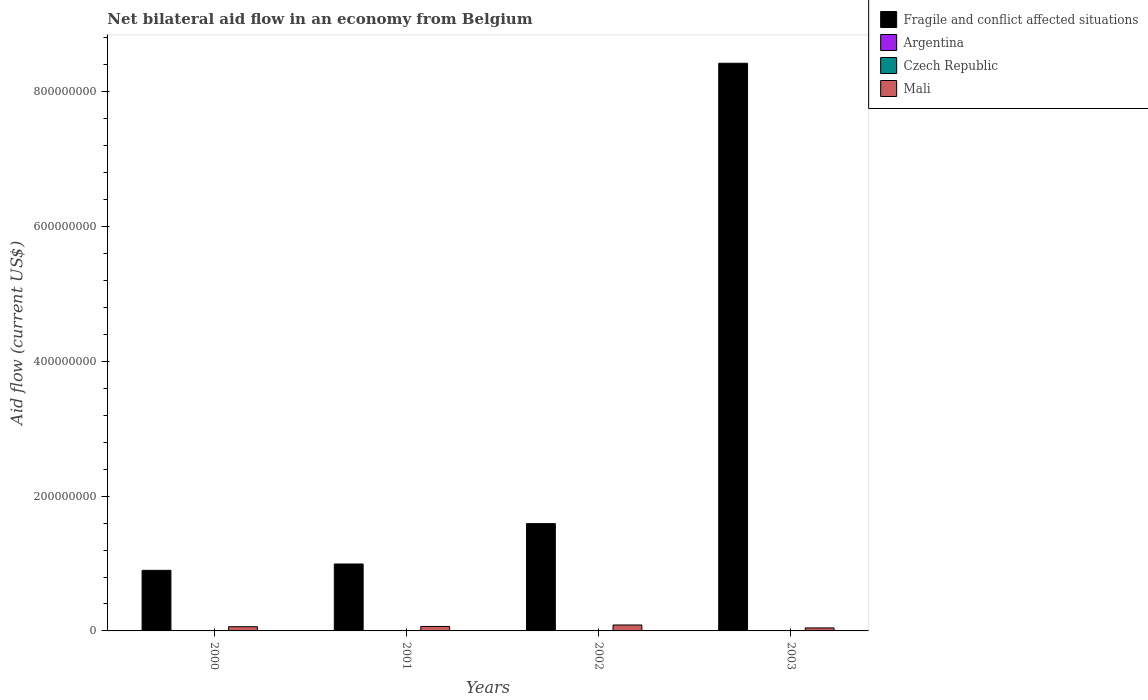How many different coloured bars are there?
Provide a short and direct response. 4. How many groups of bars are there?
Your answer should be very brief. 4. Are the number of bars on each tick of the X-axis equal?
Your answer should be very brief. Yes. What is the label of the 2nd group of bars from the left?
Give a very brief answer. 2001. Across all years, what is the maximum net bilateral aid flow in Mali?
Make the answer very short. 8.81e+06. Across all years, what is the minimum net bilateral aid flow in Fragile and conflict affected situations?
Your answer should be compact. 8.99e+07. In which year was the net bilateral aid flow in Mali maximum?
Offer a very short reply. 2002. What is the total net bilateral aid flow in Fragile and conflict affected situations in the graph?
Offer a terse response. 1.19e+09. What is the difference between the net bilateral aid flow in Mali in 2000 and that in 2001?
Keep it short and to the point. -3.70e+05. What is the difference between the net bilateral aid flow in Czech Republic in 2003 and the net bilateral aid flow in Mali in 2002?
Provide a short and direct response. -8.23e+06. What is the average net bilateral aid flow in Argentina per year?
Ensure brevity in your answer.  4.32e+05. In the year 2001, what is the difference between the net bilateral aid flow in Argentina and net bilateral aid flow in Mali?
Give a very brief answer. -6.14e+06. What is the ratio of the net bilateral aid flow in Mali in 2000 to that in 2001?
Ensure brevity in your answer.  0.94. What is the difference between the highest and the lowest net bilateral aid flow in Argentina?
Your answer should be very brief. 2.20e+05. Is it the case that in every year, the sum of the net bilateral aid flow in Argentina and net bilateral aid flow in Czech Republic is greater than the sum of net bilateral aid flow in Fragile and conflict affected situations and net bilateral aid flow in Mali?
Provide a short and direct response. No. What does the 4th bar from the right in 2001 represents?
Your answer should be very brief. Fragile and conflict affected situations. Is it the case that in every year, the sum of the net bilateral aid flow in Mali and net bilateral aid flow in Czech Republic is greater than the net bilateral aid flow in Fragile and conflict affected situations?
Provide a short and direct response. No. What is the difference between two consecutive major ticks on the Y-axis?
Give a very brief answer. 2.00e+08. Does the graph contain grids?
Provide a succinct answer. No. How are the legend labels stacked?
Ensure brevity in your answer.  Vertical. What is the title of the graph?
Offer a terse response. Net bilateral aid flow in an economy from Belgium. What is the label or title of the Y-axis?
Offer a very short reply. Aid flow (current US$). What is the Aid flow (current US$) in Fragile and conflict affected situations in 2000?
Give a very brief answer. 8.99e+07. What is the Aid flow (current US$) in Argentina in 2000?
Provide a short and direct response. 5.40e+05. What is the Aid flow (current US$) of Mali in 2000?
Offer a terse response. 6.25e+06. What is the Aid flow (current US$) of Fragile and conflict affected situations in 2001?
Give a very brief answer. 9.93e+07. What is the Aid flow (current US$) in Czech Republic in 2001?
Your answer should be very brief. 3.60e+05. What is the Aid flow (current US$) in Mali in 2001?
Make the answer very short. 6.62e+06. What is the Aid flow (current US$) in Fragile and conflict affected situations in 2002?
Ensure brevity in your answer.  1.59e+08. What is the Aid flow (current US$) of Argentina in 2002?
Offer a very short reply. 3.20e+05. What is the Aid flow (current US$) in Czech Republic in 2002?
Offer a terse response. 3.80e+05. What is the Aid flow (current US$) in Mali in 2002?
Offer a very short reply. 8.81e+06. What is the Aid flow (current US$) of Fragile and conflict affected situations in 2003?
Your answer should be compact. 8.42e+08. What is the Aid flow (current US$) of Argentina in 2003?
Make the answer very short. 3.90e+05. What is the Aid flow (current US$) of Czech Republic in 2003?
Your response must be concise. 5.80e+05. What is the Aid flow (current US$) in Mali in 2003?
Ensure brevity in your answer.  4.46e+06. Across all years, what is the maximum Aid flow (current US$) in Fragile and conflict affected situations?
Offer a very short reply. 8.42e+08. Across all years, what is the maximum Aid flow (current US$) in Argentina?
Ensure brevity in your answer.  5.40e+05. Across all years, what is the maximum Aid flow (current US$) in Czech Republic?
Keep it short and to the point. 5.80e+05. Across all years, what is the maximum Aid flow (current US$) in Mali?
Your answer should be very brief. 8.81e+06. Across all years, what is the minimum Aid flow (current US$) of Fragile and conflict affected situations?
Provide a short and direct response. 8.99e+07. Across all years, what is the minimum Aid flow (current US$) in Mali?
Give a very brief answer. 4.46e+06. What is the total Aid flow (current US$) in Fragile and conflict affected situations in the graph?
Provide a succinct answer. 1.19e+09. What is the total Aid flow (current US$) in Argentina in the graph?
Your answer should be very brief. 1.73e+06. What is the total Aid flow (current US$) in Czech Republic in the graph?
Keep it short and to the point. 1.70e+06. What is the total Aid flow (current US$) in Mali in the graph?
Make the answer very short. 2.61e+07. What is the difference between the Aid flow (current US$) of Fragile and conflict affected situations in 2000 and that in 2001?
Give a very brief answer. -9.43e+06. What is the difference between the Aid flow (current US$) of Mali in 2000 and that in 2001?
Ensure brevity in your answer.  -3.70e+05. What is the difference between the Aid flow (current US$) of Fragile and conflict affected situations in 2000 and that in 2002?
Make the answer very short. -6.93e+07. What is the difference between the Aid flow (current US$) of Mali in 2000 and that in 2002?
Your answer should be very brief. -2.56e+06. What is the difference between the Aid flow (current US$) of Fragile and conflict affected situations in 2000 and that in 2003?
Provide a short and direct response. -7.53e+08. What is the difference between the Aid flow (current US$) of Czech Republic in 2000 and that in 2003?
Make the answer very short. -2.00e+05. What is the difference between the Aid flow (current US$) in Mali in 2000 and that in 2003?
Provide a succinct answer. 1.79e+06. What is the difference between the Aid flow (current US$) of Fragile and conflict affected situations in 2001 and that in 2002?
Your response must be concise. -5.99e+07. What is the difference between the Aid flow (current US$) in Argentina in 2001 and that in 2002?
Ensure brevity in your answer.  1.60e+05. What is the difference between the Aid flow (current US$) of Czech Republic in 2001 and that in 2002?
Provide a short and direct response. -2.00e+04. What is the difference between the Aid flow (current US$) of Mali in 2001 and that in 2002?
Offer a very short reply. -2.19e+06. What is the difference between the Aid flow (current US$) in Fragile and conflict affected situations in 2001 and that in 2003?
Your answer should be very brief. -7.43e+08. What is the difference between the Aid flow (current US$) in Argentina in 2001 and that in 2003?
Ensure brevity in your answer.  9.00e+04. What is the difference between the Aid flow (current US$) of Czech Republic in 2001 and that in 2003?
Keep it short and to the point. -2.20e+05. What is the difference between the Aid flow (current US$) of Mali in 2001 and that in 2003?
Provide a succinct answer. 2.16e+06. What is the difference between the Aid flow (current US$) in Fragile and conflict affected situations in 2002 and that in 2003?
Your answer should be very brief. -6.83e+08. What is the difference between the Aid flow (current US$) in Czech Republic in 2002 and that in 2003?
Your response must be concise. -2.00e+05. What is the difference between the Aid flow (current US$) in Mali in 2002 and that in 2003?
Provide a short and direct response. 4.35e+06. What is the difference between the Aid flow (current US$) of Fragile and conflict affected situations in 2000 and the Aid flow (current US$) of Argentina in 2001?
Your answer should be compact. 8.94e+07. What is the difference between the Aid flow (current US$) in Fragile and conflict affected situations in 2000 and the Aid flow (current US$) in Czech Republic in 2001?
Your response must be concise. 8.96e+07. What is the difference between the Aid flow (current US$) in Fragile and conflict affected situations in 2000 and the Aid flow (current US$) in Mali in 2001?
Provide a succinct answer. 8.33e+07. What is the difference between the Aid flow (current US$) of Argentina in 2000 and the Aid flow (current US$) of Czech Republic in 2001?
Offer a very short reply. 1.80e+05. What is the difference between the Aid flow (current US$) of Argentina in 2000 and the Aid flow (current US$) of Mali in 2001?
Provide a short and direct response. -6.08e+06. What is the difference between the Aid flow (current US$) of Czech Republic in 2000 and the Aid flow (current US$) of Mali in 2001?
Keep it short and to the point. -6.24e+06. What is the difference between the Aid flow (current US$) of Fragile and conflict affected situations in 2000 and the Aid flow (current US$) of Argentina in 2002?
Provide a succinct answer. 8.96e+07. What is the difference between the Aid flow (current US$) in Fragile and conflict affected situations in 2000 and the Aid flow (current US$) in Czech Republic in 2002?
Make the answer very short. 8.95e+07. What is the difference between the Aid flow (current US$) in Fragile and conflict affected situations in 2000 and the Aid flow (current US$) in Mali in 2002?
Provide a succinct answer. 8.11e+07. What is the difference between the Aid flow (current US$) in Argentina in 2000 and the Aid flow (current US$) in Czech Republic in 2002?
Offer a terse response. 1.60e+05. What is the difference between the Aid flow (current US$) in Argentina in 2000 and the Aid flow (current US$) in Mali in 2002?
Offer a very short reply. -8.27e+06. What is the difference between the Aid flow (current US$) in Czech Republic in 2000 and the Aid flow (current US$) in Mali in 2002?
Make the answer very short. -8.43e+06. What is the difference between the Aid flow (current US$) of Fragile and conflict affected situations in 2000 and the Aid flow (current US$) of Argentina in 2003?
Make the answer very short. 8.95e+07. What is the difference between the Aid flow (current US$) of Fragile and conflict affected situations in 2000 and the Aid flow (current US$) of Czech Republic in 2003?
Keep it short and to the point. 8.93e+07. What is the difference between the Aid flow (current US$) in Fragile and conflict affected situations in 2000 and the Aid flow (current US$) in Mali in 2003?
Provide a short and direct response. 8.54e+07. What is the difference between the Aid flow (current US$) in Argentina in 2000 and the Aid flow (current US$) in Czech Republic in 2003?
Provide a succinct answer. -4.00e+04. What is the difference between the Aid flow (current US$) in Argentina in 2000 and the Aid flow (current US$) in Mali in 2003?
Your answer should be compact. -3.92e+06. What is the difference between the Aid flow (current US$) in Czech Republic in 2000 and the Aid flow (current US$) in Mali in 2003?
Keep it short and to the point. -4.08e+06. What is the difference between the Aid flow (current US$) of Fragile and conflict affected situations in 2001 and the Aid flow (current US$) of Argentina in 2002?
Ensure brevity in your answer.  9.90e+07. What is the difference between the Aid flow (current US$) in Fragile and conflict affected situations in 2001 and the Aid flow (current US$) in Czech Republic in 2002?
Provide a short and direct response. 9.90e+07. What is the difference between the Aid flow (current US$) of Fragile and conflict affected situations in 2001 and the Aid flow (current US$) of Mali in 2002?
Your answer should be very brief. 9.05e+07. What is the difference between the Aid flow (current US$) of Argentina in 2001 and the Aid flow (current US$) of Czech Republic in 2002?
Offer a very short reply. 1.00e+05. What is the difference between the Aid flow (current US$) of Argentina in 2001 and the Aid flow (current US$) of Mali in 2002?
Your answer should be compact. -8.33e+06. What is the difference between the Aid flow (current US$) in Czech Republic in 2001 and the Aid flow (current US$) in Mali in 2002?
Provide a short and direct response. -8.45e+06. What is the difference between the Aid flow (current US$) in Fragile and conflict affected situations in 2001 and the Aid flow (current US$) in Argentina in 2003?
Your response must be concise. 9.90e+07. What is the difference between the Aid flow (current US$) in Fragile and conflict affected situations in 2001 and the Aid flow (current US$) in Czech Republic in 2003?
Offer a terse response. 9.88e+07. What is the difference between the Aid flow (current US$) in Fragile and conflict affected situations in 2001 and the Aid flow (current US$) in Mali in 2003?
Provide a short and direct response. 9.49e+07. What is the difference between the Aid flow (current US$) in Argentina in 2001 and the Aid flow (current US$) in Czech Republic in 2003?
Make the answer very short. -1.00e+05. What is the difference between the Aid flow (current US$) in Argentina in 2001 and the Aid flow (current US$) in Mali in 2003?
Keep it short and to the point. -3.98e+06. What is the difference between the Aid flow (current US$) of Czech Republic in 2001 and the Aid flow (current US$) of Mali in 2003?
Provide a succinct answer. -4.10e+06. What is the difference between the Aid flow (current US$) in Fragile and conflict affected situations in 2002 and the Aid flow (current US$) in Argentina in 2003?
Give a very brief answer. 1.59e+08. What is the difference between the Aid flow (current US$) in Fragile and conflict affected situations in 2002 and the Aid flow (current US$) in Czech Republic in 2003?
Give a very brief answer. 1.59e+08. What is the difference between the Aid flow (current US$) in Fragile and conflict affected situations in 2002 and the Aid flow (current US$) in Mali in 2003?
Offer a terse response. 1.55e+08. What is the difference between the Aid flow (current US$) in Argentina in 2002 and the Aid flow (current US$) in Mali in 2003?
Give a very brief answer. -4.14e+06. What is the difference between the Aid flow (current US$) of Czech Republic in 2002 and the Aid flow (current US$) of Mali in 2003?
Make the answer very short. -4.08e+06. What is the average Aid flow (current US$) of Fragile and conflict affected situations per year?
Offer a very short reply. 2.98e+08. What is the average Aid flow (current US$) in Argentina per year?
Your answer should be very brief. 4.32e+05. What is the average Aid flow (current US$) in Czech Republic per year?
Give a very brief answer. 4.25e+05. What is the average Aid flow (current US$) of Mali per year?
Offer a terse response. 6.54e+06. In the year 2000, what is the difference between the Aid flow (current US$) in Fragile and conflict affected situations and Aid flow (current US$) in Argentina?
Give a very brief answer. 8.94e+07. In the year 2000, what is the difference between the Aid flow (current US$) in Fragile and conflict affected situations and Aid flow (current US$) in Czech Republic?
Provide a short and direct response. 8.95e+07. In the year 2000, what is the difference between the Aid flow (current US$) in Fragile and conflict affected situations and Aid flow (current US$) in Mali?
Your answer should be compact. 8.37e+07. In the year 2000, what is the difference between the Aid flow (current US$) of Argentina and Aid flow (current US$) of Mali?
Provide a short and direct response. -5.71e+06. In the year 2000, what is the difference between the Aid flow (current US$) of Czech Republic and Aid flow (current US$) of Mali?
Keep it short and to the point. -5.87e+06. In the year 2001, what is the difference between the Aid flow (current US$) in Fragile and conflict affected situations and Aid flow (current US$) in Argentina?
Your answer should be compact. 9.89e+07. In the year 2001, what is the difference between the Aid flow (current US$) of Fragile and conflict affected situations and Aid flow (current US$) of Czech Republic?
Give a very brief answer. 9.90e+07. In the year 2001, what is the difference between the Aid flow (current US$) of Fragile and conflict affected situations and Aid flow (current US$) of Mali?
Make the answer very short. 9.27e+07. In the year 2001, what is the difference between the Aid flow (current US$) of Argentina and Aid flow (current US$) of Czech Republic?
Keep it short and to the point. 1.20e+05. In the year 2001, what is the difference between the Aid flow (current US$) of Argentina and Aid flow (current US$) of Mali?
Ensure brevity in your answer.  -6.14e+06. In the year 2001, what is the difference between the Aid flow (current US$) of Czech Republic and Aid flow (current US$) of Mali?
Ensure brevity in your answer.  -6.26e+06. In the year 2002, what is the difference between the Aid flow (current US$) of Fragile and conflict affected situations and Aid flow (current US$) of Argentina?
Provide a short and direct response. 1.59e+08. In the year 2002, what is the difference between the Aid flow (current US$) of Fragile and conflict affected situations and Aid flow (current US$) of Czech Republic?
Make the answer very short. 1.59e+08. In the year 2002, what is the difference between the Aid flow (current US$) of Fragile and conflict affected situations and Aid flow (current US$) of Mali?
Your answer should be compact. 1.50e+08. In the year 2002, what is the difference between the Aid flow (current US$) in Argentina and Aid flow (current US$) in Czech Republic?
Your answer should be very brief. -6.00e+04. In the year 2002, what is the difference between the Aid flow (current US$) in Argentina and Aid flow (current US$) in Mali?
Your answer should be very brief. -8.49e+06. In the year 2002, what is the difference between the Aid flow (current US$) of Czech Republic and Aid flow (current US$) of Mali?
Provide a succinct answer. -8.43e+06. In the year 2003, what is the difference between the Aid flow (current US$) of Fragile and conflict affected situations and Aid flow (current US$) of Argentina?
Give a very brief answer. 8.42e+08. In the year 2003, what is the difference between the Aid flow (current US$) of Fragile and conflict affected situations and Aid flow (current US$) of Czech Republic?
Ensure brevity in your answer.  8.42e+08. In the year 2003, what is the difference between the Aid flow (current US$) in Fragile and conflict affected situations and Aid flow (current US$) in Mali?
Make the answer very short. 8.38e+08. In the year 2003, what is the difference between the Aid flow (current US$) of Argentina and Aid flow (current US$) of Czech Republic?
Give a very brief answer. -1.90e+05. In the year 2003, what is the difference between the Aid flow (current US$) in Argentina and Aid flow (current US$) in Mali?
Offer a very short reply. -4.07e+06. In the year 2003, what is the difference between the Aid flow (current US$) in Czech Republic and Aid flow (current US$) in Mali?
Make the answer very short. -3.88e+06. What is the ratio of the Aid flow (current US$) in Fragile and conflict affected situations in 2000 to that in 2001?
Give a very brief answer. 0.91. What is the ratio of the Aid flow (current US$) in Argentina in 2000 to that in 2001?
Provide a short and direct response. 1.12. What is the ratio of the Aid flow (current US$) in Czech Republic in 2000 to that in 2001?
Offer a terse response. 1.06. What is the ratio of the Aid flow (current US$) of Mali in 2000 to that in 2001?
Make the answer very short. 0.94. What is the ratio of the Aid flow (current US$) of Fragile and conflict affected situations in 2000 to that in 2002?
Give a very brief answer. 0.56. What is the ratio of the Aid flow (current US$) in Argentina in 2000 to that in 2002?
Make the answer very short. 1.69. What is the ratio of the Aid flow (current US$) in Czech Republic in 2000 to that in 2002?
Offer a terse response. 1. What is the ratio of the Aid flow (current US$) in Mali in 2000 to that in 2002?
Your answer should be compact. 0.71. What is the ratio of the Aid flow (current US$) in Fragile and conflict affected situations in 2000 to that in 2003?
Offer a terse response. 0.11. What is the ratio of the Aid flow (current US$) of Argentina in 2000 to that in 2003?
Keep it short and to the point. 1.38. What is the ratio of the Aid flow (current US$) of Czech Republic in 2000 to that in 2003?
Ensure brevity in your answer.  0.66. What is the ratio of the Aid flow (current US$) of Mali in 2000 to that in 2003?
Your answer should be compact. 1.4. What is the ratio of the Aid flow (current US$) in Fragile and conflict affected situations in 2001 to that in 2002?
Your answer should be very brief. 0.62. What is the ratio of the Aid flow (current US$) of Czech Republic in 2001 to that in 2002?
Offer a very short reply. 0.95. What is the ratio of the Aid flow (current US$) of Mali in 2001 to that in 2002?
Your answer should be compact. 0.75. What is the ratio of the Aid flow (current US$) in Fragile and conflict affected situations in 2001 to that in 2003?
Your response must be concise. 0.12. What is the ratio of the Aid flow (current US$) in Argentina in 2001 to that in 2003?
Your response must be concise. 1.23. What is the ratio of the Aid flow (current US$) in Czech Republic in 2001 to that in 2003?
Give a very brief answer. 0.62. What is the ratio of the Aid flow (current US$) of Mali in 2001 to that in 2003?
Offer a very short reply. 1.48. What is the ratio of the Aid flow (current US$) in Fragile and conflict affected situations in 2002 to that in 2003?
Provide a short and direct response. 0.19. What is the ratio of the Aid flow (current US$) of Argentina in 2002 to that in 2003?
Offer a terse response. 0.82. What is the ratio of the Aid flow (current US$) of Czech Republic in 2002 to that in 2003?
Offer a very short reply. 0.66. What is the ratio of the Aid flow (current US$) in Mali in 2002 to that in 2003?
Provide a succinct answer. 1.98. What is the difference between the highest and the second highest Aid flow (current US$) in Fragile and conflict affected situations?
Give a very brief answer. 6.83e+08. What is the difference between the highest and the second highest Aid flow (current US$) in Mali?
Offer a terse response. 2.19e+06. What is the difference between the highest and the lowest Aid flow (current US$) in Fragile and conflict affected situations?
Provide a succinct answer. 7.53e+08. What is the difference between the highest and the lowest Aid flow (current US$) in Czech Republic?
Provide a succinct answer. 2.20e+05. What is the difference between the highest and the lowest Aid flow (current US$) of Mali?
Your answer should be compact. 4.35e+06. 